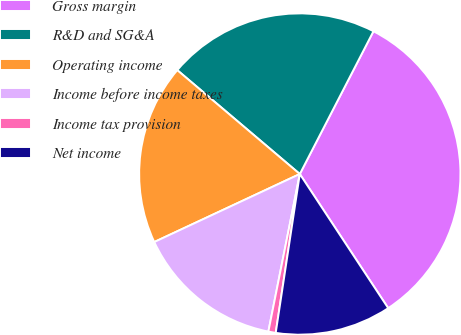Convert chart. <chart><loc_0><loc_0><loc_500><loc_500><pie_chart><fcel>Gross margin<fcel>R&D and SG&A<fcel>Operating income<fcel>Income before income taxes<fcel>Income tax provision<fcel>Net income<nl><fcel>33.15%<fcel>21.39%<fcel>18.15%<fcel>14.91%<fcel>0.74%<fcel>11.67%<nl></chart> 